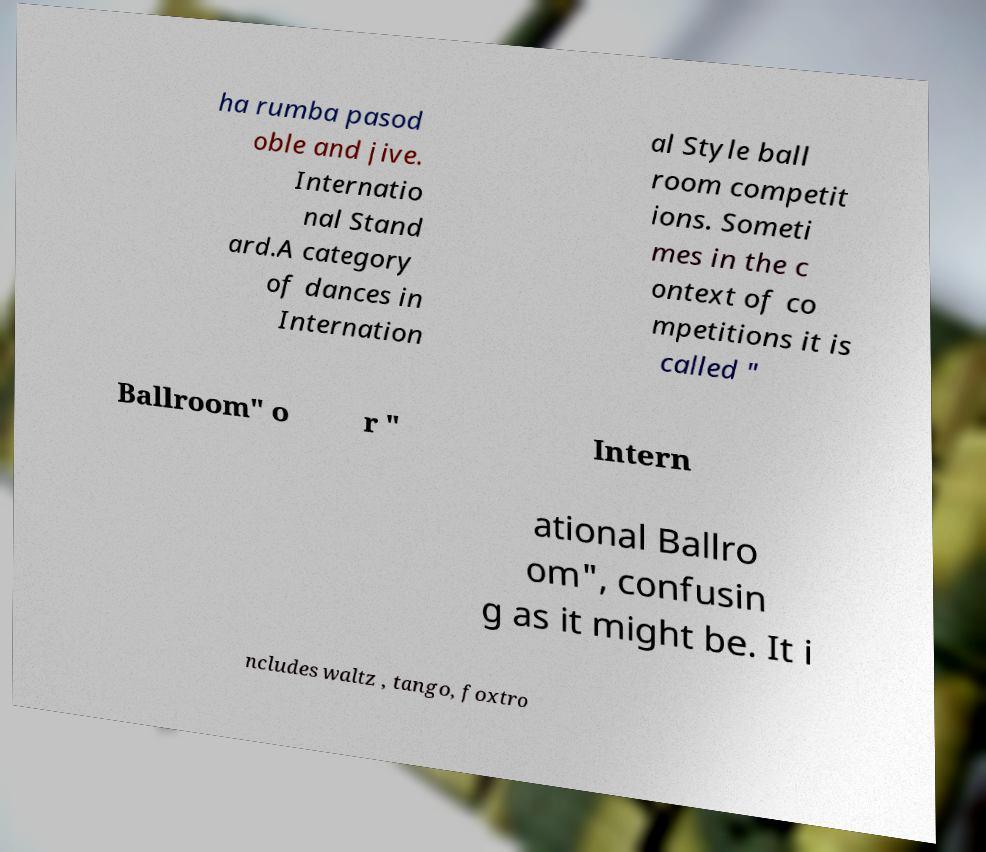What are the main characteristics of the dances mentioned in this image? The dances mentioned—cha-cha, rumba, pasodoble, and jive—are all part of Latin American ballroom dancing, known for their rhythmic movement and energetic style. The waltz, tango, and foxtrot, mentioned in reference to International Ballroom, are standard dances characterized by their fluid motion, elegance, and structured patterns. 